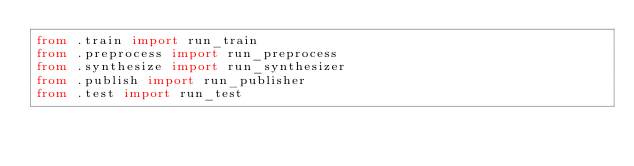Convert code to text. <code><loc_0><loc_0><loc_500><loc_500><_Python_>from .train import run_train
from .preprocess import run_preprocess
from .synthesize import run_synthesizer
from .publish import run_publisher
from .test import run_test
</code> 